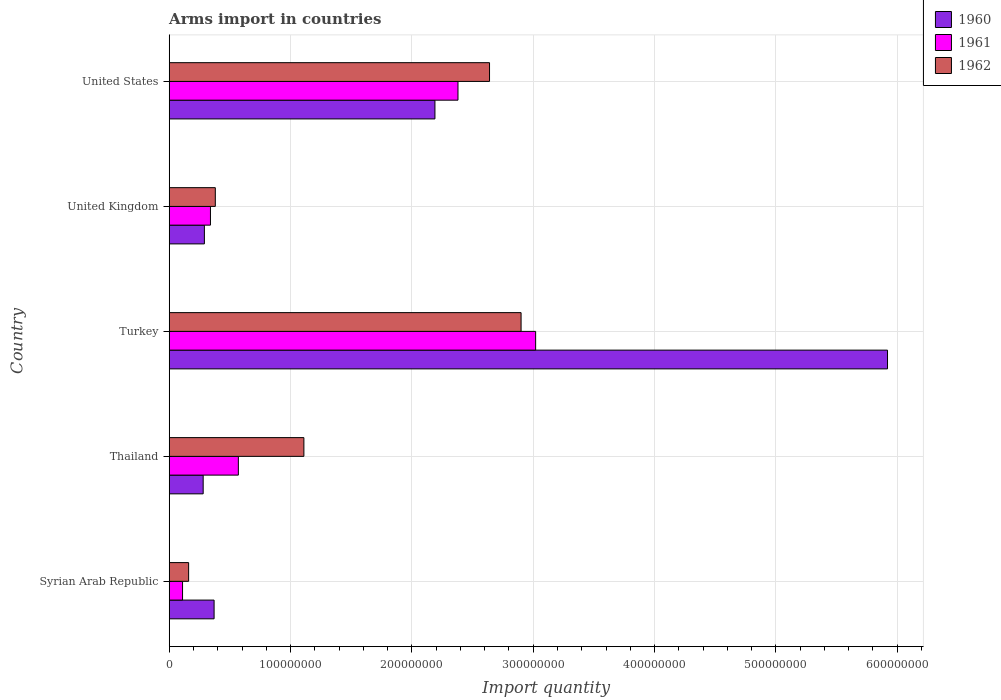Are the number of bars on each tick of the Y-axis equal?
Keep it short and to the point. Yes. How many bars are there on the 4th tick from the bottom?
Give a very brief answer. 3. What is the label of the 2nd group of bars from the top?
Provide a succinct answer. United Kingdom. In how many cases, is the number of bars for a given country not equal to the number of legend labels?
Make the answer very short. 0. What is the total arms import in 1960 in Turkey?
Offer a very short reply. 5.92e+08. Across all countries, what is the maximum total arms import in 1962?
Provide a succinct answer. 2.90e+08. Across all countries, what is the minimum total arms import in 1960?
Ensure brevity in your answer.  2.80e+07. In which country was the total arms import in 1962 minimum?
Offer a terse response. Syrian Arab Republic. What is the total total arms import in 1961 in the graph?
Offer a terse response. 6.42e+08. What is the difference between the total arms import in 1962 in Syrian Arab Republic and that in Turkey?
Give a very brief answer. -2.74e+08. What is the difference between the total arms import in 1961 in Turkey and the total arms import in 1962 in Syrian Arab Republic?
Your answer should be very brief. 2.86e+08. What is the average total arms import in 1961 per country?
Give a very brief answer. 1.28e+08. What is the difference between the total arms import in 1962 and total arms import in 1961 in Thailand?
Give a very brief answer. 5.40e+07. In how many countries, is the total arms import in 1961 greater than 120000000 ?
Your response must be concise. 2. What is the ratio of the total arms import in 1960 in Thailand to that in United States?
Offer a very short reply. 0.13. Is the total arms import in 1961 in Thailand less than that in United Kingdom?
Provide a short and direct response. No. Is the difference between the total arms import in 1962 in Syrian Arab Republic and Thailand greater than the difference between the total arms import in 1961 in Syrian Arab Republic and Thailand?
Provide a succinct answer. No. What is the difference between the highest and the second highest total arms import in 1961?
Offer a very short reply. 6.40e+07. What is the difference between the highest and the lowest total arms import in 1960?
Your answer should be very brief. 5.64e+08. Is the sum of the total arms import in 1960 in Turkey and United States greater than the maximum total arms import in 1961 across all countries?
Give a very brief answer. Yes. What does the 2nd bar from the bottom in Thailand represents?
Your response must be concise. 1961. Is it the case that in every country, the sum of the total arms import in 1960 and total arms import in 1961 is greater than the total arms import in 1962?
Provide a short and direct response. No. Are the values on the major ticks of X-axis written in scientific E-notation?
Keep it short and to the point. No. Does the graph contain any zero values?
Offer a terse response. No. Does the graph contain grids?
Ensure brevity in your answer.  Yes. Where does the legend appear in the graph?
Ensure brevity in your answer.  Top right. What is the title of the graph?
Offer a very short reply. Arms import in countries. Does "1993" appear as one of the legend labels in the graph?
Keep it short and to the point. No. What is the label or title of the X-axis?
Keep it short and to the point. Import quantity. What is the Import quantity of 1960 in Syrian Arab Republic?
Offer a terse response. 3.70e+07. What is the Import quantity of 1961 in Syrian Arab Republic?
Offer a terse response. 1.10e+07. What is the Import quantity of 1962 in Syrian Arab Republic?
Offer a very short reply. 1.60e+07. What is the Import quantity of 1960 in Thailand?
Your answer should be very brief. 2.80e+07. What is the Import quantity of 1961 in Thailand?
Provide a short and direct response. 5.70e+07. What is the Import quantity in 1962 in Thailand?
Offer a terse response. 1.11e+08. What is the Import quantity in 1960 in Turkey?
Offer a very short reply. 5.92e+08. What is the Import quantity of 1961 in Turkey?
Your response must be concise. 3.02e+08. What is the Import quantity of 1962 in Turkey?
Your answer should be very brief. 2.90e+08. What is the Import quantity in 1960 in United Kingdom?
Your response must be concise. 2.90e+07. What is the Import quantity in 1961 in United Kingdom?
Ensure brevity in your answer.  3.40e+07. What is the Import quantity of 1962 in United Kingdom?
Your answer should be compact. 3.80e+07. What is the Import quantity of 1960 in United States?
Offer a very short reply. 2.19e+08. What is the Import quantity in 1961 in United States?
Your answer should be compact. 2.38e+08. What is the Import quantity in 1962 in United States?
Give a very brief answer. 2.64e+08. Across all countries, what is the maximum Import quantity of 1960?
Your answer should be very brief. 5.92e+08. Across all countries, what is the maximum Import quantity of 1961?
Make the answer very short. 3.02e+08. Across all countries, what is the maximum Import quantity in 1962?
Provide a short and direct response. 2.90e+08. Across all countries, what is the minimum Import quantity of 1960?
Ensure brevity in your answer.  2.80e+07. Across all countries, what is the minimum Import quantity of 1961?
Your answer should be very brief. 1.10e+07. Across all countries, what is the minimum Import quantity in 1962?
Your answer should be compact. 1.60e+07. What is the total Import quantity of 1960 in the graph?
Make the answer very short. 9.05e+08. What is the total Import quantity of 1961 in the graph?
Make the answer very short. 6.42e+08. What is the total Import quantity in 1962 in the graph?
Offer a terse response. 7.19e+08. What is the difference between the Import quantity in 1960 in Syrian Arab Republic and that in Thailand?
Ensure brevity in your answer.  9.00e+06. What is the difference between the Import quantity of 1961 in Syrian Arab Republic and that in Thailand?
Your response must be concise. -4.60e+07. What is the difference between the Import quantity of 1962 in Syrian Arab Republic and that in Thailand?
Ensure brevity in your answer.  -9.50e+07. What is the difference between the Import quantity of 1960 in Syrian Arab Republic and that in Turkey?
Offer a terse response. -5.55e+08. What is the difference between the Import quantity in 1961 in Syrian Arab Republic and that in Turkey?
Ensure brevity in your answer.  -2.91e+08. What is the difference between the Import quantity in 1962 in Syrian Arab Republic and that in Turkey?
Keep it short and to the point. -2.74e+08. What is the difference between the Import quantity in 1960 in Syrian Arab Republic and that in United Kingdom?
Give a very brief answer. 8.00e+06. What is the difference between the Import quantity in 1961 in Syrian Arab Republic and that in United Kingdom?
Your answer should be compact. -2.30e+07. What is the difference between the Import quantity in 1962 in Syrian Arab Republic and that in United Kingdom?
Provide a succinct answer. -2.20e+07. What is the difference between the Import quantity in 1960 in Syrian Arab Republic and that in United States?
Make the answer very short. -1.82e+08. What is the difference between the Import quantity of 1961 in Syrian Arab Republic and that in United States?
Make the answer very short. -2.27e+08. What is the difference between the Import quantity of 1962 in Syrian Arab Republic and that in United States?
Your answer should be very brief. -2.48e+08. What is the difference between the Import quantity in 1960 in Thailand and that in Turkey?
Your response must be concise. -5.64e+08. What is the difference between the Import quantity in 1961 in Thailand and that in Turkey?
Ensure brevity in your answer.  -2.45e+08. What is the difference between the Import quantity of 1962 in Thailand and that in Turkey?
Provide a succinct answer. -1.79e+08. What is the difference between the Import quantity of 1960 in Thailand and that in United Kingdom?
Offer a terse response. -1.00e+06. What is the difference between the Import quantity of 1961 in Thailand and that in United Kingdom?
Keep it short and to the point. 2.30e+07. What is the difference between the Import quantity of 1962 in Thailand and that in United Kingdom?
Keep it short and to the point. 7.30e+07. What is the difference between the Import quantity of 1960 in Thailand and that in United States?
Give a very brief answer. -1.91e+08. What is the difference between the Import quantity of 1961 in Thailand and that in United States?
Your response must be concise. -1.81e+08. What is the difference between the Import quantity of 1962 in Thailand and that in United States?
Offer a very short reply. -1.53e+08. What is the difference between the Import quantity of 1960 in Turkey and that in United Kingdom?
Provide a succinct answer. 5.63e+08. What is the difference between the Import quantity of 1961 in Turkey and that in United Kingdom?
Ensure brevity in your answer.  2.68e+08. What is the difference between the Import quantity in 1962 in Turkey and that in United Kingdom?
Your response must be concise. 2.52e+08. What is the difference between the Import quantity of 1960 in Turkey and that in United States?
Provide a short and direct response. 3.73e+08. What is the difference between the Import quantity in 1961 in Turkey and that in United States?
Keep it short and to the point. 6.40e+07. What is the difference between the Import quantity of 1962 in Turkey and that in United States?
Provide a succinct answer. 2.60e+07. What is the difference between the Import quantity of 1960 in United Kingdom and that in United States?
Offer a terse response. -1.90e+08. What is the difference between the Import quantity of 1961 in United Kingdom and that in United States?
Make the answer very short. -2.04e+08. What is the difference between the Import quantity of 1962 in United Kingdom and that in United States?
Make the answer very short. -2.26e+08. What is the difference between the Import quantity of 1960 in Syrian Arab Republic and the Import quantity of 1961 in Thailand?
Make the answer very short. -2.00e+07. What is the difference between the Import quantity in 1960 in Syrian Arab Republic and the Import quantity in 1962 in Thailand?
Make the answer very short. -7.40e+07. What is the difference between the Import quantity in 1961 in Syrian Arab Republic and the Import quantity in 1962 in Thailand?
Give a very brief answer. -1.00e+08. What is the difference between the Import quantity in 1960 in Syrian Arab Republic and the Import quantity in 1961 in Turkey?
Keep it short and to the point. -2.65e+08. What is the difference between the Import quantity in 1960 in Syrian Arab Republic and the Import quantity in 1962 in Turkey?
Make the answer very short. -2.53e+08. What is the difference between the Import quantity in 1961 in Syrian Arab Republic and the Import quantity in 1962 in Turkey?
Give a very brief answer. -2.79e+08. What is the difference between the Import quantity of 1960 in Syrian Arab Republic and the Import quantity of 1961 in United Kingdom?
Offer a very short reply. 3.00e+06. What is the difference between the Import quantity in 1961 in Syrian Arab Republic and the Import quantity in 1962 in United Kingdom?
Make the answer very short. -2.70e+07. What is the difference between the Import quantity in 1960 in Syrian Arab Republic and the Import quantity in 1961 in United States?
Your answer should be compact. -2.01e+08. What is the difference between the Import quantity of 1960 in Syrian Arab Republic and the Import quantity of 1962 in United States?
Offer a terse response. -2.27e+08. What is the difference between the Import quantity of 1961 in Syrian Arab Republic and the Import quantity of 1962 in United States?
Your answer should be compact. -2.53e+08. What is the difference between the Import quantity in 1960 in Thailand and the Import quantity in 1961 in Turkey?
Ensure brevity in your answer.  -2.74e+08. What is the difference between the Import quantity of 1960 in Thailand and the Import quantity of 1962 in Turkey?
Keep it short and to the point. -2.62e+08. What is the difference between the Import quantity of 1961 in Thailand and the Import quantity of 1962 in Turkey?
Your answer should be very brief. -2.33e+08. What is the difference between the Import quantity in 1960 in Thailand and the Import quantity in 1961 in United Kingdom?
Ensure brevity in your answer.  -6.00e+06. What is the difference between the Import quantity of 1960 in Thailand and the Import quantity of 1962 in United Kingdom?
Your response must be concise. -1.00e+07. What is the difference between the Import quantity in 1961 in Thailand and the Import quantity in 1962 in United Kingdom?
Offer a terse response. 1.90e+07. What is the difference between the Import quantity in 1960 in Thailand and the Import quantity in 1961 in United States?
Give a very brief answer. -2.10e+08. What is the difference between the Import quantity of 1960 in Thailand and the Import quantity of 1962 in United States?
Give a very brief answer. -2.36e+08. What is the difference between the Import quantity of 1961 in Thailand and the Import quantity of 1962 in United States?
Your answer should be compact. -2.07e+08. What is the difference between the Import quantity in 1960 in Turkey and the Import quantity in 1961 in United Kingdom?
Make the answer very short. 5.58e+08. What is the difference between the Import quantity of 1960 in Turkey and the Import quantity of 1962 in United Kingdom?
Keep it short and to the point. 5.54e+08. What is the difference between the Import quantity of 1961 in Turkey and the Import quantity of 1962 in United Kingdom?
Ensure brevity in your answer.  2.64e+08. What is the difference between the Import quantity of 1960 in Turkey and the Import quantity of 1961 in United States?
Your answer should be compact. 3.54e+08. What is the difference between the Import quantity of 1960 in Turkey and the Import quantity of 1962 in United States?
Offer a very short reply. 3.28e+08. What is the difference between the Import quantity of 1961 in Turkey and the Import quantity of 1962 in United States?
Make the answer very short. 3.80e+07. What is the difference between the Import quantity in 1960 in United Kingdom and the Import quantity in 1961 in United States?
Keep it short and to the point. -2.09e+08. What is the difference between the Import quantity in 1960 in United Kingdom and the Import quantity in 1962 in United States?
Your response must be concise. -2.35e+08. What is the difference between the Import quantity in 1961 in United Kingdom and the Import quantity in 1962 in United States?
Your response must be concise. -2.30e+08. What is the average Import quantity of 1960 per country?
Ensure brevity in your answer.  1.81e+08. What is the average Import quantity of 1961 per country?
Your answer should be compact. 1.28e+08. What is the average Import quantity in 1962 per country?
Keep it short and to the point. 1.44e+08. What is the difference between the Import quantity of 1960 and Import quantity of 1961 in Syrian Arab Republic?
Keep it short and to the point. 2.60e+07. What is the difference between the Import quantity of 1960 and Import quantity of 1962 in Syrian Arab Republic?
Provide a succinct answer. 2.10e+07. What is the difference between the Import quantity in 1961 and Import quantity in 1962 in Syrian Arab Republic?
Provide a succinct answer. -5.00e+06. What is the difference between the Import quantity of 1960 and Import quantity of 1961 in Thailand?
Your response must be concise. -2.90e+07. What is the difference between the Import quantity in 1960 and Import quantity in 1962 in Thailand?
Keep it short and to the point. -8.30e+07. What is the difference between the Import quantity in 1961 and Import quantity in 1962 in Thailand?
Your answer should be compact. -5.40e+07. What is the difference between the Import quantity of 1960 and Import quantity of 1961 in Turkey?
Provide a short and direct response. 2.90e+08. What is the difference between the Import quantity of 1960 and Import quantity of 1962 in Turkey?
Your answer should be compact. 3.02e+08. What is the difference between the Import quantity of 1961 and Import quantity of 1962 in Turkey?
Your answer should be very brief. 1.20e+07. What is the difference between the Import quantity of 1960 and Import quantity of 1961 in United Kingdom?
Your answer should be compact. -5.00e+06. What is the difference between the Import quantity of 1960 and Import quantity of 1962 in United Kingdom?
Provide a succinct answer. -9.00e+06. What is the difference between the Import quantity of 1960 and Import quantity of 1961 in United States?
Keep it short and to the point. -1.90e+07. What is the difference between the Import quantity of 1960 and Import quantity of 1962 in United States?
Give a very brief answer. -4.50e+07. What is the difference between the Import quantity of 1961 and Import quantity of 1962 in United States?
Provide a succinct answer. -2.60e+07. What is the ratio of the Import quantity of 1960 in Syrian Arab Republic to that in Thailand?
Your answer should be very brief. 1.32. What is the ratio of the Import quantity of 1961 in Syrian Arab Republic to that in Thailand?
Ensure brevity in your answer.  0.19. What is the ratio of the Import quantity in 1962 in Syrian Arab Republic to that in Thailand?
Provide a short and direct response. 0.14. What is the ratio of the Import quantity of 1960 in Syrian Arab Republic to that in Turkey?
Give a very brief answer. 0.06. What is the ratio of the Import quantity of 1961 in Syrian Arab Republic to that in Turkey?
Provide a short and direct response. 0.04. What is the ratio of the Import quantity of 1962 in Syrian Arab Republic to that in Turkey?
Your response must be concise. 0.06. What is the ratio of the Import quantity of 1960 in Syrian Arab Republic to that in United Kingdom?
Your answer should be very brief. 1.28. What is the ratio of the Import quantity of 1961 in Syrian Arab Republic to that in United Kingdom?
Offer a terse response. 0.32. What is the ratio of the Import quantity of 1962 in Syrian Arab Republic to that in United Kingdom?
Your response must be concise. 0.42. What is the ratio of the Import quantity in 1960 in Syrian Arab Republic to that in United States?
Provide a short and direct response. 0.17. What is the ratio of the Import quantity of 1961 in Syrian Arab Republic to that in United States?
Your answer should be compact. 0.05. What is the ratio of the Import quantity of 1962 in Syrian Arab Republic to that in United States?
Provide a short and direct response. 0.06. What is the ratio of the Import quantity in 1960 in Thailand to that in Turkey?
Ensure brevity in your answer.  0.05. What is the ratio of the Import quantity in 1961 in Thailand to that in Turkey?
Your response must be concise. 0.19. What is the ratio of the Import quantity in 1962 in Thailand to that in Turkey?
Keep it short and to the point. 0.38. What is the ratio of the Import quantity of 1960 in Thailand to that in United Kingdom?
Your answer should be very brief. 0.97. What is the ratio of the Import quantity in 1961 in Thailand to that in United Kingdom?
Make the answer very short. 1.68. What is the ratio of the Import quantity of 1962 in Thailand to that in United Kingdom?
Offer a very short reply. 2.92. What is the ratio of the Import quantity in 1960 in Thailand to that in United States?
Keep it short and to the point. 0.13. What is the ratio of the Import quantity in 1961 in Thailand to that in United States?
Keep it short and to the point. 0.24. What is the ratio of the Import quantity in 1962 in Thailand to that in United States?
Offer a terse response. 0.42. What is the ratio of the Import quantity in 1960 in Turkey to that in United Kingdom?
Provide a succinct answer. 20.41. What is the ratio of the Import quantity of 1961 in Turkey to that in United Kingdom?
Your response must be concise. 8.88. What is the ratio of the Import quantity in 1962 in Turkey to that in United Kingdom?
Offer a very short reply. 7.63. What is the ratio of the Import quantity in 1960 in Turkey to that in United States?
Offer a terse response. 2.7. What is the ratio of the Import quantity in 1961 in Turkey to that in United States?
Keep it short and to the point. 1.27. What is the ratio of the Import quantity in 1962 in Turkey to that in United States?
Offer a terse response. 1.1. What is the ratio of the Import quantity of 1960 in United Kingdom to that in United States?
Your answer should be compact. 0.13. What is the ratio of the Import quantity of 1961 in United Kingdom to that in United States?
Your response must be concise. 0.14. What is the ratio of the Import quantity in 1962 in United Kingdom to that in United States?
Offer a terse response. 0.14. What is the difference between the highest and the second highest Import quantity in 1960?
Ensure brevity in your answer.  3.73e+08. What is the difference between the highest and the second highest Import quantity in 1961?
Offer a very short reply. 6.40e+07. What is the difference between the highest and the second highest Import quantity of 1962?
Offer a very short reply. 2.60e+07. What is the difference between the highest and the lowest Import quantity of 1960?
Offer a very short reply. 5.64e+08. What is the difference between the highest and the lowest Import quantity in 1961?
Offer a terse response. 2.91e+08. What is the difference between the highest and the lowest Import quantity of 1962?
Keep it short and to the point. 2.74e+08. 